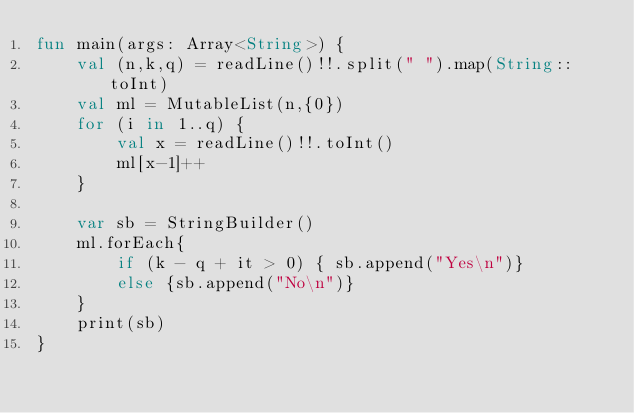Convert code to text. <code><loc_0><loc_0><loc_500><loc_500><_Kotlin_>fun main(args: Array<String>) {
    val (n,k,q) = readLine()!!.split(" ").map(String::toInt)
    val ml = MutableList(n,{0})
    for (i in 1..q) {
        val x = readLine()!!.toInt()
        ml[x-1]++
    }

    var sb = StringBuilder()
    ml.forEach{
        if (k - q + it > 0) { sb.append("Yes\n")}
        else {sb.append("No\n")}
    }
    print(sb)
}</code> 